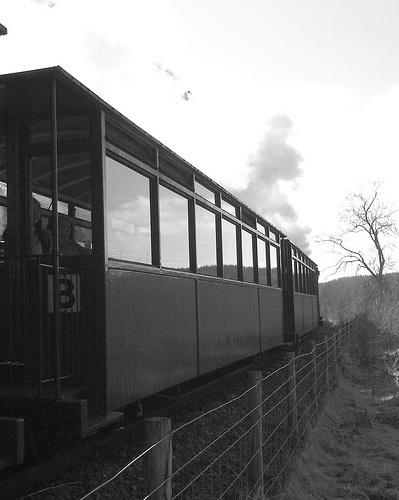Describe the environment surrounding the train. The train is traveling through a rural landscape with trees and open fields visible in the background. The sky is clear, enhancing the serene rural setting. 